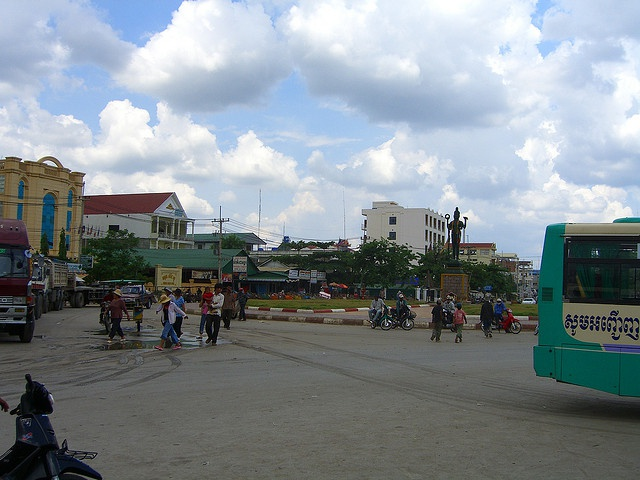Describe the objects in this image and their specific colors. I can see bus in lightblue, teal, black, gray, and darkgreen tones, motorcycle in lightblue, black, gray, and darkblue tones, truck in lightblue, black, and gray tones, people in lightblue, black, gray, darkgreen, and maroon tones, and truck in lightblue, black, gray, and darkgreen tones in this image. 